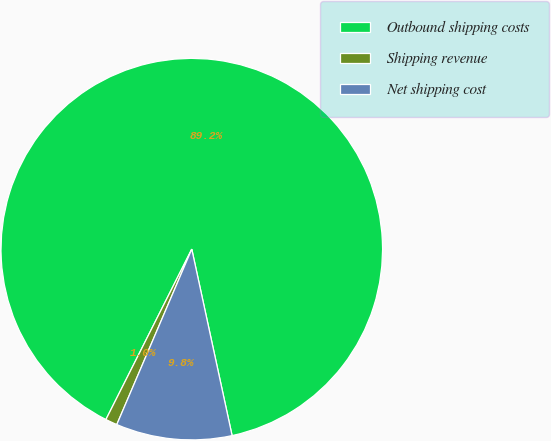Convert chart. <chart><loc_0><loc_0><loc_500><loc_500><pie_chart><fcel>Outbound shipping costs<fcel>Shipping revenue<fcel>Net shipping cost<nl><fcel>89.18%<fcel>1.0%<fcel>9.82%<nl></chart> 